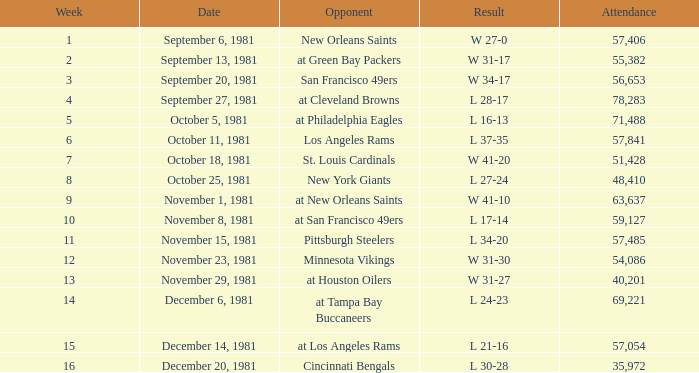What was the highest number of attendance in a week before 8 and game on October 25, 1981? None. Help me parse the entirety of this table. {'header': ['Week', 'Date', 'Opponent', 'Result', 'Attendance'], 'rows': [['1', 'September 6, 1981', 'New Orleans Saints', 'W 27-0', '57,406'], ['2', 'September 13, 1981', 'at Green Bay Packers', 'W 31-17', '55,382'], ['3', 'September 20, 1981', 'San Francisco 49ers', 'W 34-17', '56,653'], ['4', 'September 27, 1981', 'at Cleveland Browns', 'L 28-17', '78,283'], ['5', 'October 5, 1981', 'at Philadelphia Eagles', 'L 16-13', '71,488'], ['6', 'October 11, 1981', 'Los Angeles Rams', 'L 37-35', '57,841'], ['7', 'October 18, 1981', 'St. Louis Cardinals', 'W 41-20', '51,428'], ['8', 'October 25, 1981', 'New York Giants', 'L 27-24', '48,410'], ['9', 'November 1, 1981', 'at New Orleans Saints', 'W 41-10', '63,637'], ['10', 'November 8, 1981', 'at San Francisco 49ers', 'L 17-14', '59,127'], ['11', 'November 15, 1981', 'Pittsburgh Steelers', 'L 34-20', '57,485'], ['12', 'November 23, 1981', 'Minnesota Vikings', 'W 31-30', '54,086'], ['13', 'November 29, 1981', 'at Houston Oilers', 'W 31-27', '40,201'], ['14', 'December 6, 1981', 'at Tampa Bay Buccaneers', 'L 24-23', '69,221'], ['15', 'December 14, 1981', 'at Los Angeles Rams', 'L 21-16', '57,054'], ['16', 'December 20, 1981', 'Cincinnati Bengals', 'L 30-28', '35,972']]} 